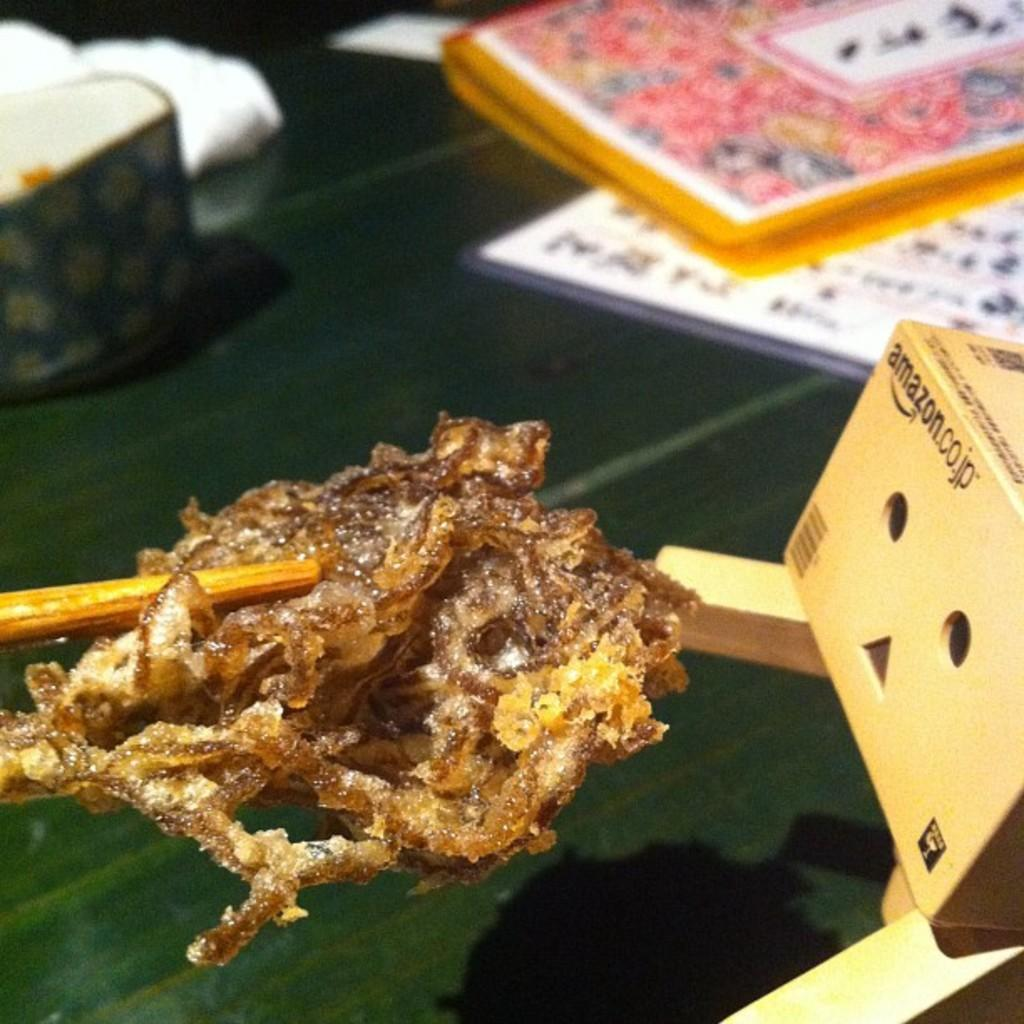What is the food item with a chopstick in the image? The food item with a chopstick in the image is not specified, but it is present. What type of container is visible in the image? There is a cardboard box in the image. Can you describe the background of the image? The background of the image contains objects, but their specific nature is not mentioned. Is there a dock visible in the image? No, there is no dock present in the image. What type of surprise is hidden in the cardboard box? There is no mention of a surprise in the image, and the contents of the cardboard box are not specified. 